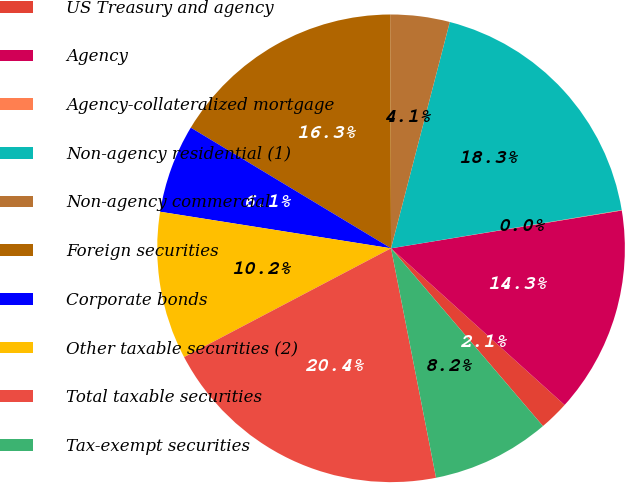Convert chart to OTSL. <chart><loc_0><loc_0><loc_500><loc_500><pie_chart><fcel>US Treasury and agency<fcel>Agency<fcel>Agency-collateralized mortgage<fcel>Non-agency residential (1)<fcel>Non-agency commercial<fcel>Foreign securities<fcel>Corporate bonds<fcel>Other taxable securities (2)<fcel>Total taxable securities<fcel>Tax-exempt securities<nl><fcel>2.06%<fcel>14.27%<fcel>0.03%<fcel>18.34%<fcel>4.1%<fcel>16.31%<fcel>6.13%<fcel>10.2%<fcel>20.38%<fcel>8.17%<nl></chart> 